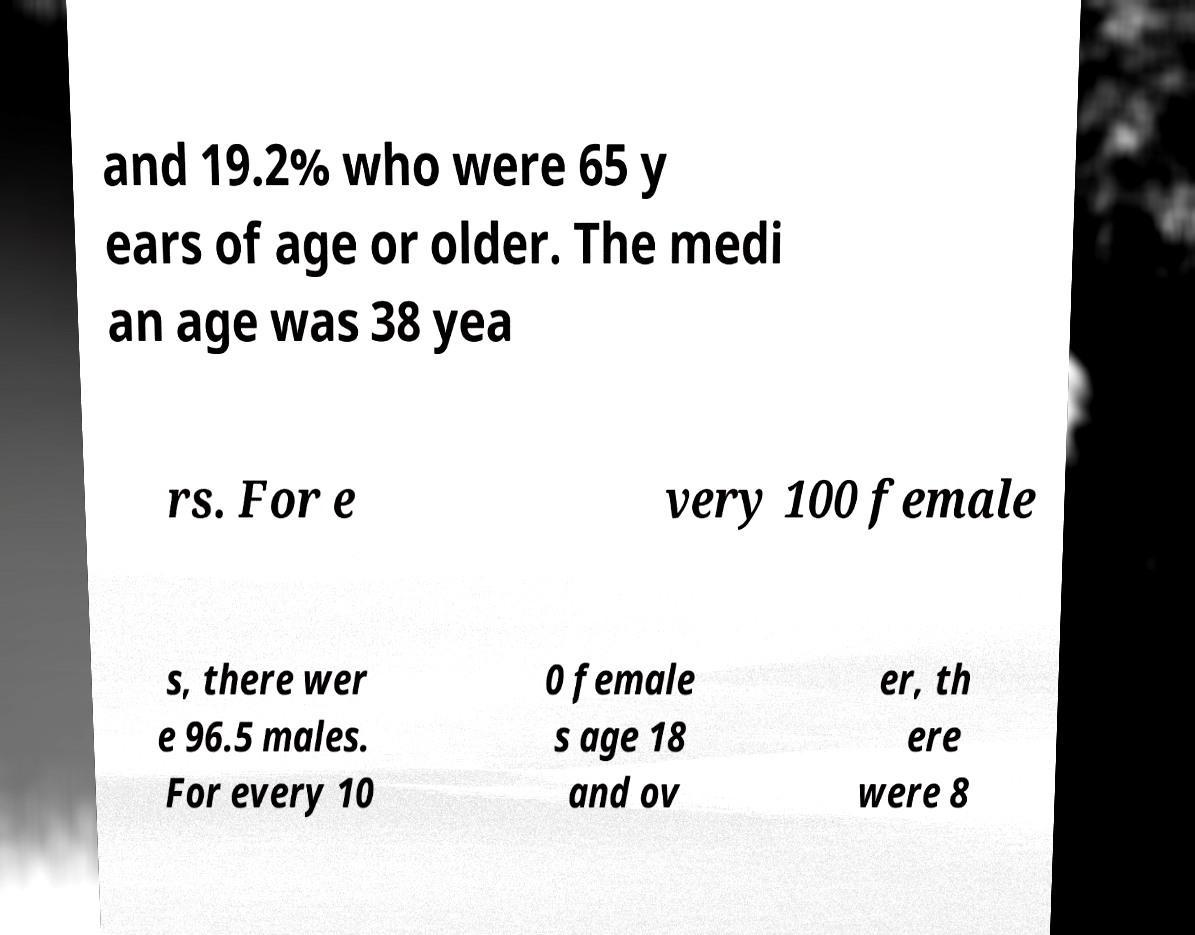For documentation purposes, I need the text within this image transcribed. Could you provide that? and 19.2% who were 65 y ears of age or older. The medi an age was 38 yea rs. For e very 100 female s, there wer e 96.5 males. For every 10 0 female s age 18 and ov er, th ere were 8 